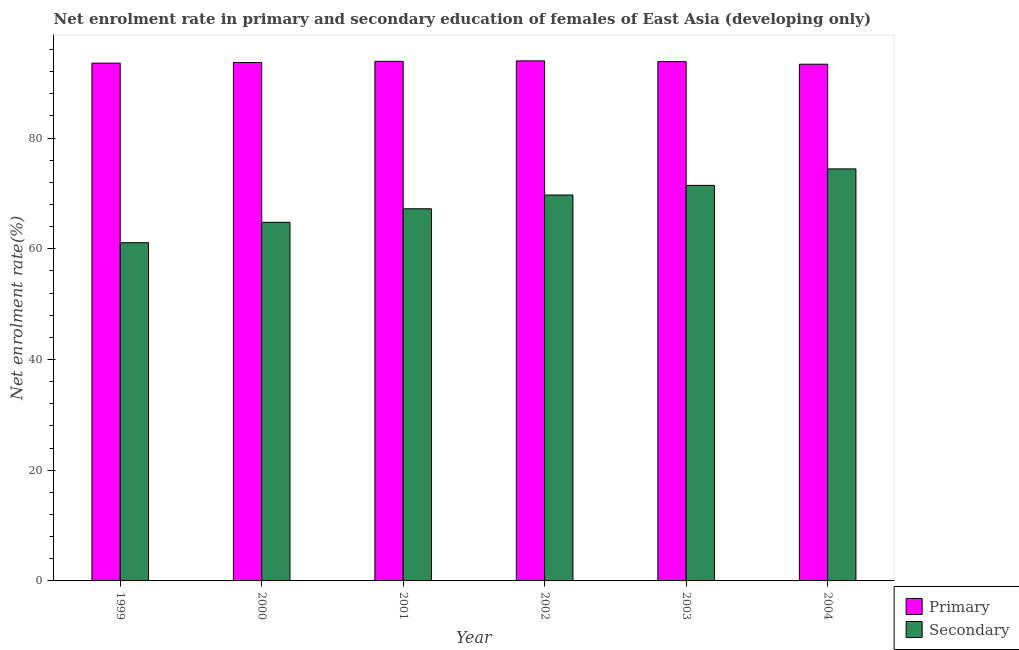How many different coloured bars are there?
Offer a terse response. 2. Are the number of bars on each tick of the X-axis equal?
Offer a very short reply. Yes. How many bars are there on the 2nd tick from the left?
Give a very brief answer. 2. How many bars are there on the 2nd tick from the right?
Give a very brief answer. 2. In how many cases, is the number of bars for a given year not equal to the number of legend labels?
Offer a terse response. 0. What is the enrollment rate in primary education in 2002?
Give a very brief answer. 93.93. Across all years, what is the maximum enrollment rate in secondary education?
Offer a very short reply. 74.42. Across all years, what is the minimum enrollment rate in primary education?
Provide a short and direct response. 93.33. In which year was the enrollment rate in secondary education maximum?
Your answer should be compact. 2004. What is the total enrollment rate in primary education in the graph?
Make the answer very short. 562.09. What is the difference between the enrollment rate in primary education in 1999 and that in 2002?
Provide a short and direct response. -0.41. What is the difference between the enrollment rate in secondary education in 2004 and the enrollment rate in primary education in 1999?
Ensure brevity in your answer.  13.33. What is the average enrollment rate in secondary education per year?
Provide a succinct answer. 68.11. In how many years, is the enrollment rate in primary education greater than 48 %?
Your answer should be very brief. 6. What is the ratio of the enrollment rate in primary education in 1999 to that in 2004?
Offer a very short reply. 1. Is the enrollment rate in secondary education in 2000 less than that in 2002?
Your answer should be very brief. Yes. What is the difference between the highest and the second highest enrollment rate in secondary education?
Make the answer very short. 2.98. What is the difference between the highest and the lowest enrollment rate in primary education?
Make the answer very short. 0.61. In how many years, is the enrollment rate in primary education greater than the average enrollment rate in primary education taken over all years?
Give a very brief answer. 3. Is the sum of the enrollment rate in secondary education in 1999 and 2003 greater than the maximum enrollment rate in primary education across all years?
Your response must be concise. Yes. What does the 2nd bar from the left in 2000 represents?
Keep it short and to the point. Secondary. What does the 2nd bar from the right in 2002 represents?
Provide a succinct answer. Primary. Are all the bars in the graph horizontal?
Your response must be concise. No. Does the graph contain any zero values?
Offer a very short reply. No. Does the graph contain grids?
Ensure brevity in your answer.  No. Where does the legend appear in the graph?
Your answer should be very brief. Bottom right. How many legend labels are there?
Make the answer very short. 2. How are the legend labels stacked?
Keep it short and to the point. Vertical. What is the title of the graph?
Your answer should be compact. Net enrolment rate in primary and secondary education of females of East Asia (developing only). Does "Sanitation services" appear as one of the legend labels in the graph?
Make the answer very short. No. What is the label or title of the X-axis?
Provide a short and direct response. Year. What is the label or title of the Y-axis?
Ensure brevity in your answer.  Net enrolment rate(%). What is the Net enrolment rate(%) of Primary in 1999?
Your answer should be very brief. 93.52. What is the Net enrolment rate(%) in Secondary in 1999?
Your response must be concise. 61.09. What is the Net enrolment rate(%) in Primary in 2000?
Ensure brevity in your answer.  93.64. What is the Net enrolment rate(%) of Secondary in 2000?
Your answer should be very brief. 64.77. What is the Net enrolment rate(%) in Primary in 2001?
Keep it short and to the point. 93.85. What is the Net enrolment rate(%) of Secondary in 2001?
Provide a short and direct response. 67.22. What is the Net enrolment rate(%) in Primary in 2002?
Give a very brief answer. 93.93. What is the Net enrolment rate(%) in Secondary in 2002?
Your answer should be very brief. 69.71. What is the Net enrolment rate(%) of Primary in 2003?
Offer a terse response. 93.81. What is the Net enrolment rate(%) of Secondary in 2003?
Your answer should be compact. 71.45. What is the Net enrolment rate(%) of Primary in 2004?
Your response must be concise. 93.33. What is the Net enrolment rate(%) of Secondary in 2004?
Make the answer very short. 74.42. Across all years, what is the maximum Net enrolment rate(%) of Primary?
Offer a very short reply. 93.93. Across all years, what is the maximum Net enrolment rate(%) of Secondary?
Keep it short and to the point. 74.42. Across all years, what is the minimum Net enrolment rate(%) in Primary?
Offer a terse response. 93.33. Across all years, what is the minimum Net enrolment rate(%) of Secondary?
Ensure brevity in your answer.  61.09. What is the total Net enrolment rate(%) of Primary in the graph?
Provide a short and direct response. 562.09. What is the total Net enrolment rate(%) in Secondary in the graph?
Offer a very short reply. 408.66. What is the difference between the Net enrolment rate(%) in Primary in 1999 and that in 2000?
Offer a very short reply. -0.12. What is the difference between the Net enrolment rate(%) in Secondary in 1999 and that in 2000?
Your response must be concise. -3.68. What is the difference between the Net enrolment rate(%) of Primary in 1999 and that in 2001?
Make the answer very short. -0.33. What is the difference between the Net enrolment rate(%) of Secondary in 1999 and that in 2001?
Ensure brevity in your answer.  -6.13. What is the difference between the Net enrolment rate(%) in Primary in 1999 and that in 2002?
Provide a succinct answer. -0.41. What is the difference between the Net enrolment rate(%) in Secondary in 1999 and that in 2002?
Your answer should be very brief. -8.62. What is the difference between the Net enrolment rate(%) of Primary in 1999 and that in 2003?
Your answer should be compact. -0.28. What is the difference between the Net enrolment rate(%) of Secondary in 1999 and that in 2003?
Your answer should be compact. -10.35. What is the difference between the Net enrolment rate(%) of Primary in 1999 and that in 2004?
Your answer should be very brief. 0.2. What is the difference between the Net enrolment rate(%) of Secondary in 1999 and that in 2004?
Your response must be concise. -13.33. What is the difference between the Net enrolment rate(%) in Primary in 2000 and that in 2001?
Provide a short and direct response. -0.21. What is the difference between the Net enrolment rate(%) in Secondary in 2000 and that in 2001?
Give a very brief answer. -2.44. What is the difference between the Net enrolment rate(%) in Primary in 2000 and that in 2002?
Offer a very short reply. -0.29. What is the difference between the Net enrolment rate(%) in Secondary in 2000 and that in 2002?
Provide a succinct answer. -4.93. What is the difference between the Net enrolment rate(%) of Primary in 2000 and that in 2003?
Provide a succinct answer. -0.16. What is the difference between the Net enrolment rate(%) in Secondary in 2000 and that in 2003?
Provide a succinct answer. -6.67. What is the difference between the Net enrolment rate(%) in Primary in 2000 and that in 2004?
Keep it short and to the point. 0.31. What is the difference between the Net enrolment rate(%) in Secondary in 2000 and that in 2004?
Offer a very short reply. -9.65. What is the difference between the Net enrolment rate(%) of Primary in 2001 and that in 2002?
Provide a short and direct response. -0.09. What is the difference between the Net enrolment rate(%) in Secondary in 2001 and that in 2002?
Your answer should be compact. -2.49. What is the difference between the Net enrolment rate(%) of Primary in 2001 and that in 2003?
Make the answer very short. 0.04. What is the difference between the Net enrolment rate(%) of Secondary in 2001 and that in 2003?
Provide a short and direct response. -4.23. What is the difference between the Net enrolment rate(%) of Primary in 2001 and that in 2004?
Make the answer very short. 0.52. What is the difference between the Net enrolment rate(%) in Secondary in 2001 and that in 2004?
Offer a very short reply. -7.2. What is the difference between the Net enrolment rate(%) in Primary in 2002 and that in 2003?
Offer a very short reply. 0.13. What is the difference between the Net enrolment rate(%) in Secondary in 2002 and that in 2003?
Your answer should be compact. -1.74. What is the difference between the Net enrolment rate(%) in Primary in 2002 and that in 2004?
Keep it short and to the point. 0.61. What is the difference between the Net enrolment rate(%) of Secondary in 2002 and that in 2004?
Your answer should be very brief. -4.71. What is the difference between the Net enrolment rate(%) in Primary in 2003 and that in 2004?
Your answer should be compact. 0.48. What is the difference between the Net enrolment rate(%) of Secondary in 2003 and that in 2004?
Provide a succinct answer. -2.98. What is the difference between the Net enrolment rate(%) of Primary in 1999 and the Net enrolment rate(%) of Secondary in 2000?
Make the answer very short. 28.75. What is the difference between the Net enrolment rate(%) in Primary in 1999 and the Net enrolment rate(%) in Secondary in 2001?
Your answer should be compact. 26.3. What is the difference between the Net enrolment rate(%) of Primary in 1999 and the Net enrolment rate(%) of Secondary in 2002?
Your answer should be very brief. 23.82. What is the difference between the Net enrolment rate(%) in Primary in 1999 and the Net enrolment rate(%) in Secondary in 2003?
Give a very brief answer. 22.08. What is the difference between the Net enrolment rate(%) in Primary in 1999 and the Net enrolment rate(%) in Secondary in 2004?
Your answer should be very brief. 19.1. What is the difference between the Net enrolment rate(%) in Primary in 2000 and the Net enrolment rate(%) in Secondary in 2001?
Provide a short and direct response. 26.42. What is the difference between the Net enrolment rate(%) of Primary in 2000 and the Net enrolment rate(%) of Secondary in 2002?
Make the answer very short. 23.94. What is the difference between the Net enrolment rate(%) in Primary in 2000 and the Net enrolment rate(%) in Secondary in 2003?
Your response must be concise. 22.2. What is the difference between the Net enrolment rate(%) in Primary in 2000 and the Net enrolment rate(%) in Secondary in 2004?
Make the answer very short. 19.22. What is the difference between the Net enrolment rate(%) of Primary in 2001 and the Net enrolment rate(%) of Secondary in 2002?
Make the answer very short. 24.14. What is the difference between the Net enrolment rate(%) in Primary in 2001 and the Net enrolment rate(%) in Secondary in 2003?
Keep it short and to the point. 22.4. What is the difference between the Net enrolment rate(%) of Primary in 2001 and the Net enrolment rate(%) of Secondary in 2004?
Your answer should be compact. 19.43. What is the difference between the Net enrolment rate(%) of Primary in 2002 and the Net enrolment rate(%) of Secondary in 2003?
Offer a very short reply. 22.49. What is the difference between the Net enrolment rate(%) in Primary in 2002 and the Net enrolment rate(%) in Secondary in 2004?
Keep it short and to the point. 19.51. What is the difference between the Net enrolment rate(%) of Primary in 2003 and the Net enrolment rate(%) of Secondary in 2004?
Keep it short and to the point. 19.39. What is the average Net enrolment rate(%) of Primary per year?
Offer a terse response. 93.68. What is the average Net enrolment rate(%) of Secondary per year?
Your answer should be very brief. 68.11. In the year 1999, what is the difference between the Net enrolment rate(%) of Primary and Net enrolment rate(%) of Secondary?
Your answer should be compact. 32.43. In the year 2000, what is the difference between the Net enrolment rate(%) in Primary and Net enrolment rate(%) in Secondary?
Provide a succinct answer. 28.87. In the year 2001, what is the difference between the Net enrolment rate(%) in Primary and Net enrolment rate(%) in Secondary?
Offer a terse response. 26.63. In the year 2002, what is the difference between the Net enrolment rate(%) of Primary and Net enrolment rate(%) of Secondary?
Offer a terse response. 24.23. In the year 2003, what is the difference between the Net enrolment rate(%) in Primary and Net enrolment rate(%) in Secondary?
Provide a succinct answer. 22.36. In the year 2004, what is the difference between the Net enrolment rate(%) of Primary and Net enrolment rate(%) of Secondary?
Give a very brief answer. 18.91. What is the ratio of the Net enrolment rate(%) in Primary in 1999 to that in 2000?
Offer a very short reply. 1. What is the ratio of the Net enrolment rate(%) of Secondary in 1999 to that in 2000?
Offer a terse response. 0.94. What is the ratio of the Net enrolment rate(%) of Primary in 1999 to that in 2001?
Offer a very short reply. 1. What is the ratio of the Net enrolment rate(%) in Secondary in 1999 to that in 2001?
Offer a very short reply. 0.91. What is the ratio of the Net enrolment rate(%) in Secondary in 1999 to that in 2002?
Your answer should be very brief. 0.88. What is the ratio of the Net enrolment rate(%) of Primary in 1999 to that in 2003?
Make the answer very short. 1. What is the ratio of the Net enrolment rate(%) in Secondary in 1999 to that in 2003?
Make the answer very short. 0.86. What is the ratio of the Net enrolment rate(%) in Secondary in 1999 to that in 2004?
Offer a terse response. 0.82. What is the ratio of the Net enrolment rate(%) of Secondary in 2000 to that in 2001?
Make the answer very short. 0.96. What is the ratio of the Net enrolment rate(%) of Primary in 2000 to that in 2002?
Give a very brief answer. 1. What is the ratio of the Net enrolment rate(%) in Secondary in 2000 to that in 2002?
Offer a very short reply. 0.93. What is the ratio of the Net enrolment rate(%) in Secondary in 2000 to that in 2003?
Your answer should be very brief. 0.91. What is the ratio of the Net enrolment rate(%) in Secondary in 2000 to that in 2004?
Make the answer very short. 0.87. What is the ratio of the Net enrolment rate(%) in Primary in 2001 to that in 2002?
Your answer should be compact. 1. What is the ratio of the Net enrolment rate(%) of Secondary in 2001 to that in 2003?
Offer a very short reply. 0.94. What is the ratio of the Net enrolment rate(%) of Primary in 2001 to that in 2004?
Your answer should be compact. 1.01. What is the ratio of the Net enrolment rate(%) of Secondary in 2001 to that in 2004?
Make the answer very short. 0.9. What is the ratio of the Net enrolment rate(%) of Secondary in 2002 to that in 2003?
Offer a terse response. 0.98. What is the ratio of the Net enrolment rate(%) in Primary in 2002 to that in 2004?
Provide a succinct answer. 1.01. What is the ratio of the Net enrolment rate(%) in Secondary in 2002 to that in 2004?
Your answer should be very brief. 0.94. What is the difference between the highest and the second highest Net enrolment rate(%) in Primary?
Offer a very short reply. 0.09. What is the difference between the highest and the second highest Net enrolment rate(%) of Secondary?
Provide a succinct answer. 2.98. What is the difference between the highest and the lowest Net enrolment rate(%) of Primary?
Your response must be concise. 0.61. What is the difference between the highest and the lowest Net enrolment rate(%) of Secondary?
Keep it short and to the point. 13.33. 